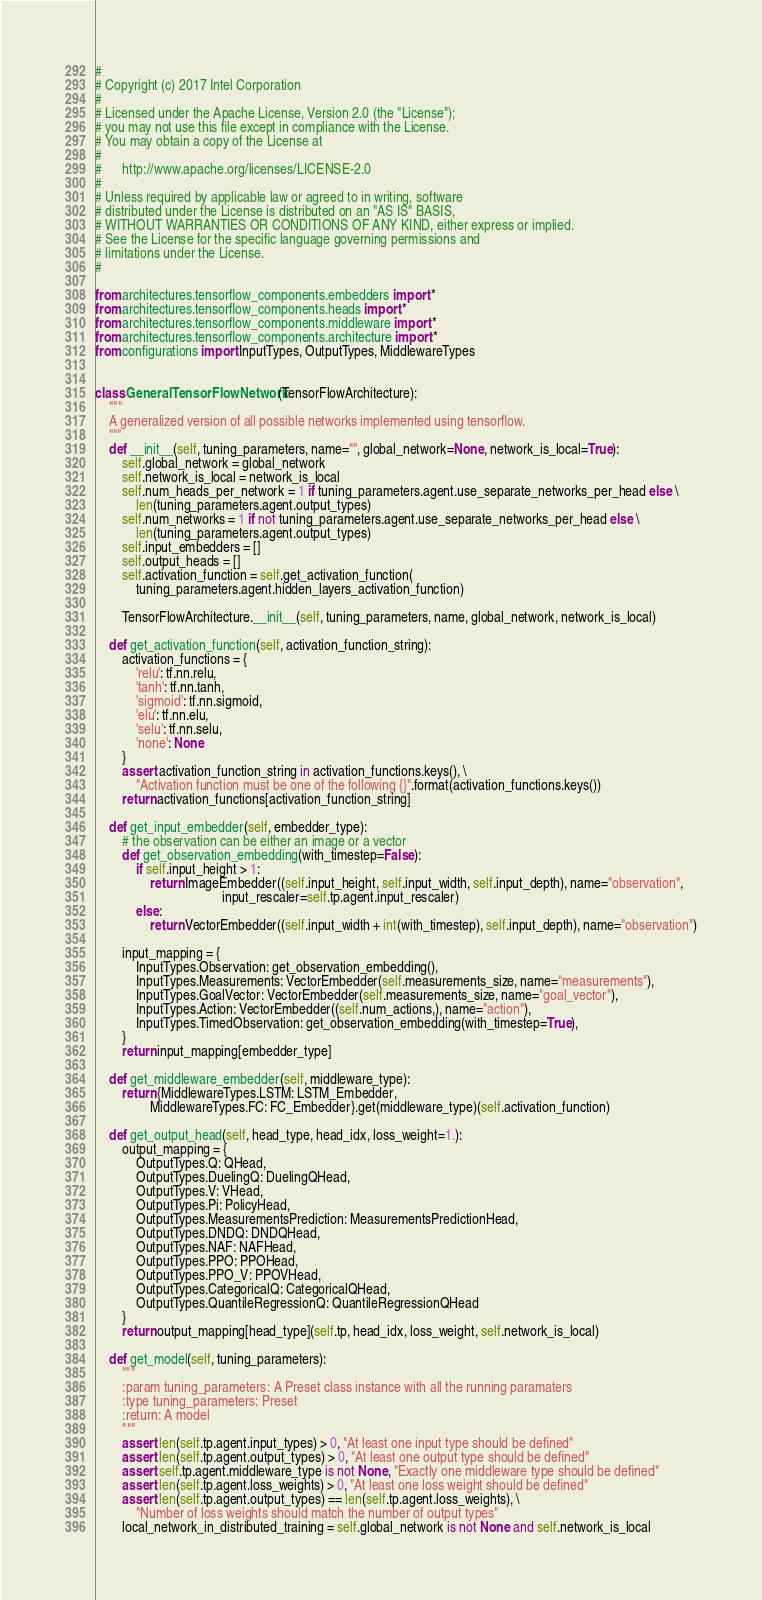<code> <loc_0><loc_0><loc_500><loc_500><_Python_>#
# Copyright (c) 2017 Intel Corporation
#
# Licensed under the Apache License, Version 2.0 (the "License");
# you may not use this file except in compliance with the License.
# You may obtain a copy of the License at
#
#      http://www.apache.org/licenses/LICENSE-2.0
#
# Unless required by applicable law or agreed to in writing, software
# distributed under the License is distributed on an "AS IS" BASIS,
# WITHOUT WARRANTIES OR CONDITIONS OF ANY KIND, either express or implied.
# See the License for the specific language governing permissions and
# limitations under the License.
#

from architectures.tensorflow_components.embedders import *
from architectures.tensorflow_components.heads import *
from architectures.tensorflow_components.middleware import *
from architectures.tensorflow_components.architecture import *
from configurations import InputTypes, OutputTypes, MiddlewareTypes


class GeneralTensorFlowNetwork(TensorFlowArchitecture):
    """
    A generalized version of all possible networks implemented using tensorflow.
    """
    def __init__(self, tuning_parameters, name="", global_network=None, network_is_local=True):
        self.global_network = global_network
        self.network_is_local = network_is_local
        self.num_heads_per_network = 1 if tuning_parameters.agent.use_separate_networks_per_head else \
            len(tuning_parameters.agent.output_types)
        self.num_networks = 1 if not tuning_parameters.agent.use_separate_networks_per_head else \
            len(tuning_parameters.agent.output_types)
        self.input_embedders = []
        self.output_heads = []
        self.activation_function = self.get_activation_function(
            tuning_parameters.agent.hidden_layers_activation_function)

        TensorFlowArchitecture.__init__(self, tuning_parameters, name, global_network, network_is_local)

    def get_activation_function(self, activation_function_string):
        activation_functions = {
            'relu': tf.nn.relu,
            'tanh': tf.nn.tanh,
            'sigmoid': tf.nn.sigmoid,
            'elu': tf.nn.elu,
            'selu': tf.nn.selu,
            'none': None
        }
        assert activation_function_string in activation_functions.keys(), \
            "Activation function must be one of the following {}".format(activation_functions.keys())
        return activation_functions[activation_function_string]

    def get_input_embedder(self, embedder_type):
        # the observation can be either an image or a vector
        def get_observation_embedding(with_timestep=False):
            if self.input_height > 1:
                return ImageEmbedder((self.input_height, self.input_width, self.input_depth), name="observation",
                                     input_rescaler=self.tp.agent.input_rescaler)
            else:
                return VectorEmbedder((self.input_width + int(with_timestep), self.input_depth), name="observation")

        input_mapping = {
            InputTypes.Observation: get_observation_embedding(),
            InputTypes.Measurements: VectorEmbedder(self.measurements_size, name="measurements"),
            InputTypes.GoalVector: VectorEmbedder(self.measurements_size, name="goal_vector"),
            InputTypes.Action: VectorEmbedder((self.num_actions,), name="action"),
            InputTypes.TimedObservation: get_observation_embedding(with_timestep=True),
        }
        return input_mapping[embedder_type]

    def get_middleware_embedder(self, middleware_type):
        return {MiddlewareTypes.LSTM: LSTM_Embedder,
                MiddlewareTypes.FC: FC_Embedder}.get(middleware_type)(self.activation_function)

    def get_output_head(self, head_type, head_idx, loss_weight=1.):
        output_mapping = {
            OutputTypes.Q: QHead,
            OutputTypes.DuelingQ: DuelingQHead,
            OutputTypes.V: VHead,
            OutputTypes.Pi: PolicyHead,
            OutputTypes.MeasurementsPrediction: MeasurementsPredictionHead,
            OutputTypes.DNDQ: DNDQHead,
            OutputTypes.NAF: NAFHead,
            OutputTypes.PPO: PPOHead,
            OutputTypes.PPO_V: PPOVHead,
            OutputTypes.CategoricalQ: CategoricalQHead,
            OutputTypes.QuantileRegressionQ: QuantileRegressionQHead
        }
        return output_mapping[head_type](self.tp, head_idx, loss_weight, self.network_is_local)

    def get_model(self, tuning_parameters):
        """
        :param tuning_parameters: A Preset class instance with all the running paramaters
        :type tuning_parameters: Preset
        :return: A model
        """
        assert len(self.tp.agent.input_types) > 0, "At least one input type should be defined"
        assert len(self.tp.agent.output_types) > 0, "At least one output type should be defined"
        assert self.tp.agent.middleware_type is not None, "Exactly one middleware type should be defined"
        assert len(self.tp.agent.loss_weights) > 0, "At least one loss weight should be defined"
        assert len(self.tp.agent.output_types) == len(self.tp.agent.loss_weights), \
            "Number of loss weights should match the number of output types"
        local_network_in_distributed_training = self.global_network is not None and self.network_is_local
</code> 